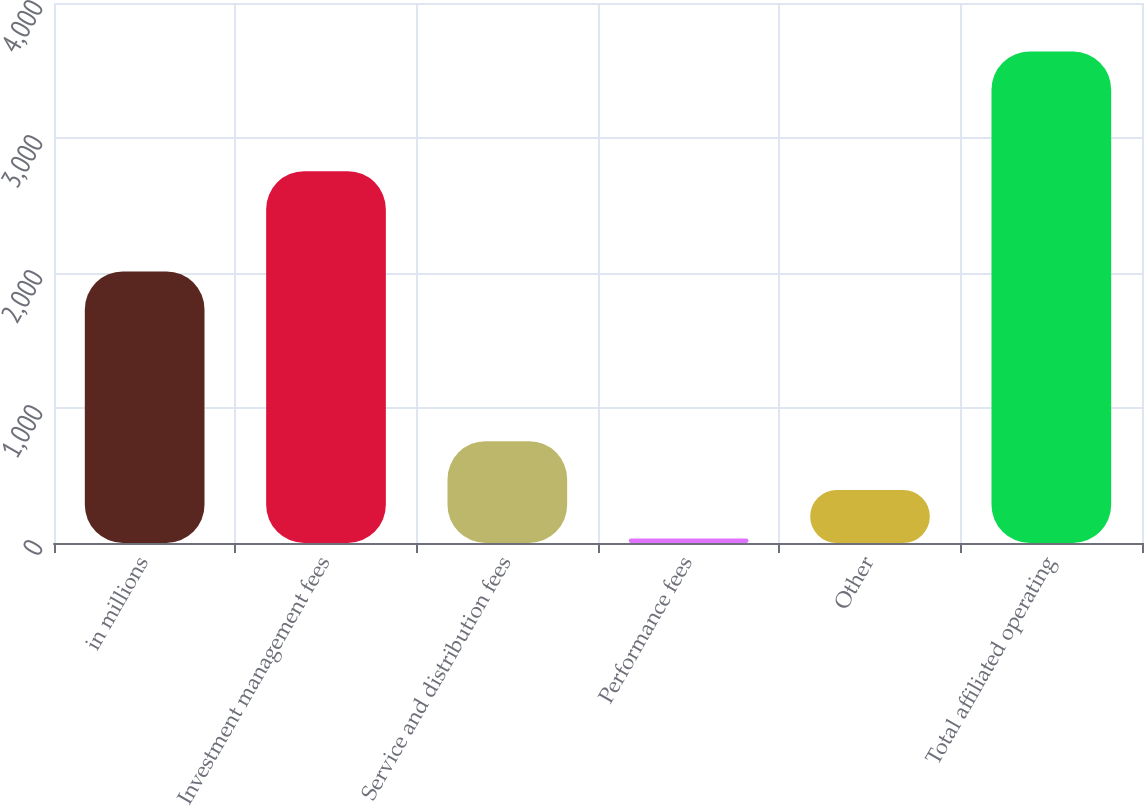Convert chart to OTSL. <chart><loc_0><loc_0><loc_500><loc_500><bar_chart><fcel>in millions<fcel>Investment management fees<fcel>Service and distribution fees<fcel>Performance fees<fcel>Other<fcel>Total affiliated operating<nl><fcel>2012<fcel>2754.2<fcel>754.16<fcel>32.6<fcel>393.38<fcel>3640.4<nl></chart> 